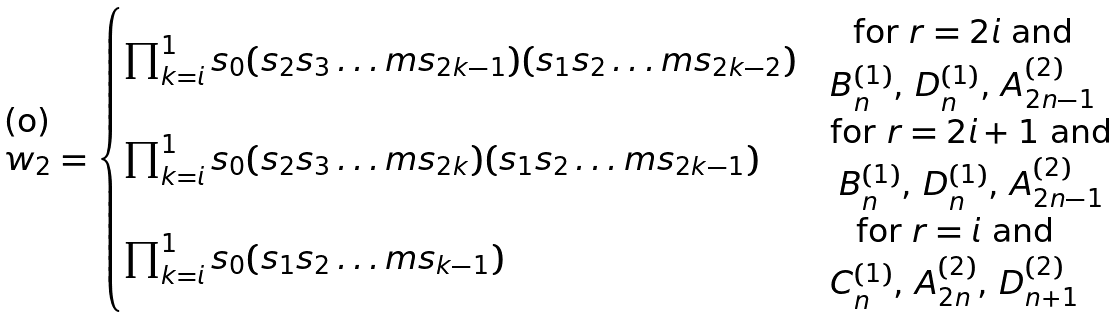<formula> <loc_0><loc_0><loc_500><loc_500>w _ { 2 } = \begin{cases} \prod _ { k = i } ^ { 1 } s _ { 0 } ( s _ { 2 } s _ { 3 } \dots m s _ { 2 k - 1 } ) ( s _ { 1 } s _ { 2 } \dots m s _ { 2 k - 2 } ) & \begin{matrix} \text {for $r=2i$ and} \\ \text {$B_{n}^{(1)}$, $D_{n}^{(1)}$, $A_{2n-1}^{(2)}$} \end{matrix} \\ \prod _ { k = i } ^ { 1 } s _ { 0 } ( s _ { 2 } s _ { 3 } \dots m s _ { 2 k } ) ( s _ { 1 } s _ { 2 } \dots m s _ { 2 k - 1 } ) & \begin{matrix} \text {for $r=2i+1$ and} \\ \text {$B_{n}^{(1)}$, $D_{n}^{(1)}$, $A_{2n-1}^{(2)}$} \end{matrix} \\ \prod _ { k = i } ^ { 1 } s _ { 0 } ( s _ { 1 } s _ { 2 } \dots m s _ { k - 1 } ) & \begin{matrix} \text {for $r=i$ and} \\ \text {$C_{n}^{(1)}$, $A_{2n}^{(2)}$, $D_{n+1}^{(2)}$} \end{matrix} \end{cases}</formula> 